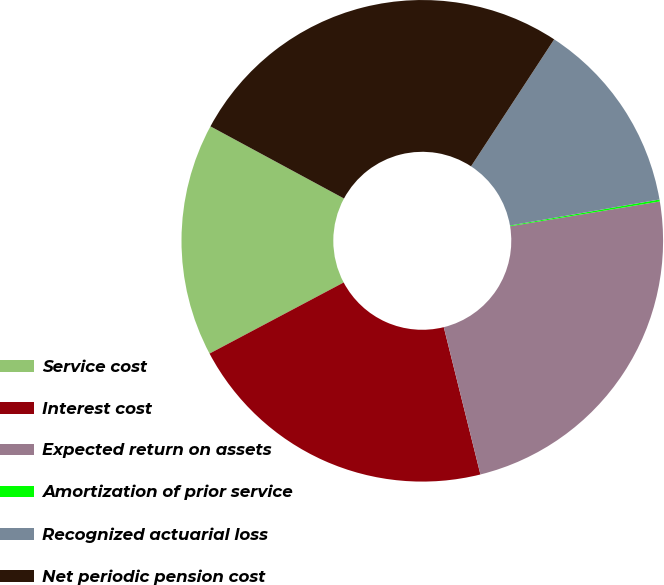Convert chart to OTSL. <chart><loc_0><loc_0><loc_500><loc_500><pie_chart><fcel>Service cost<fcel>Interest cost<fcel>Expected return on assets<fcel>Amortization of prior service<fcel>Recognized actuarial loss<fcel>Net periodic pension cost<nl><fcel>15.64%<fcel>21.12%<fcel>23.73%<fcel>0.13%<fcel>13.03%<fcel>26.34%<nl></chart> 